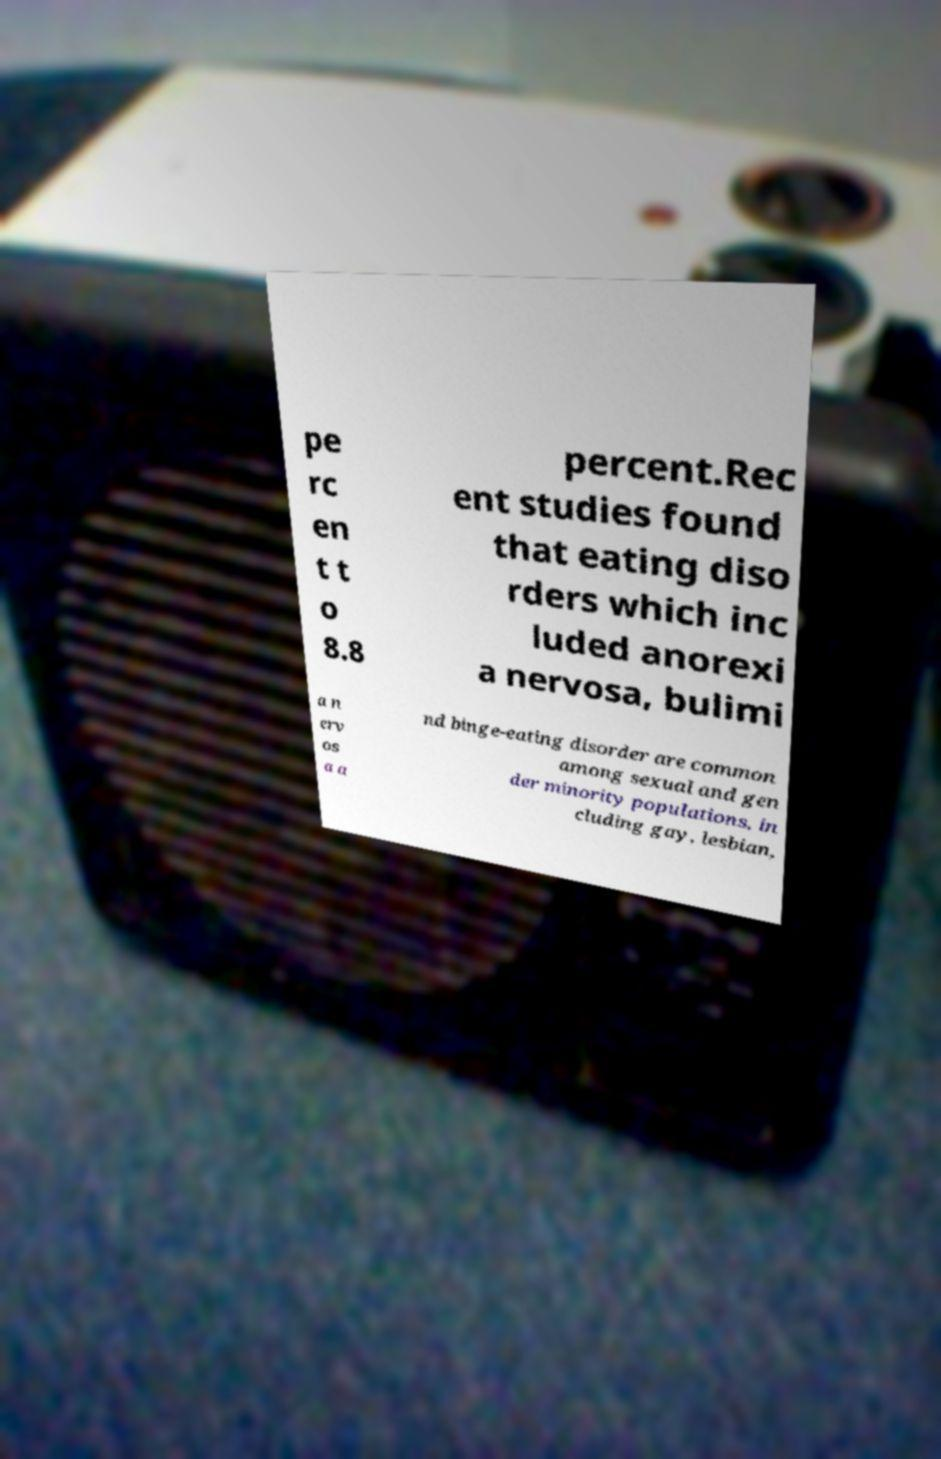Could you assist in decoding the text presented in this image and type it out clearly? pe rc en t t o 8.8 percent.Rec ent studies found that eating diso rders which inc luded anorexi a nervosa, bulimi a n erv os a a nd binge-eating disorder are common among sexual and gen der minority populations, in cluding gay, lesbian, 